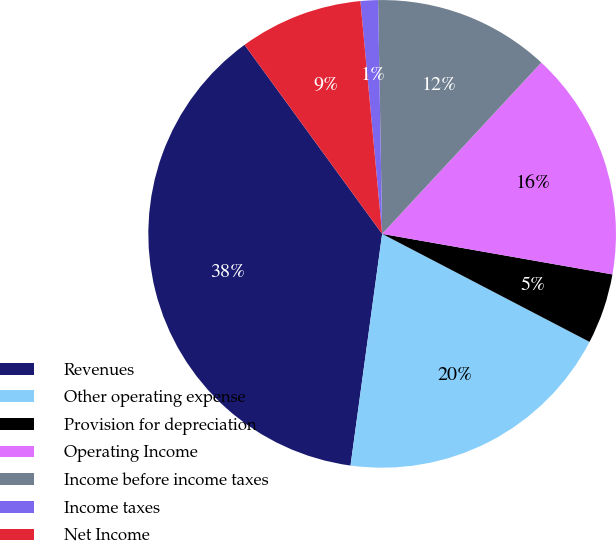Convert chart to OTSL. <chart><loc_0><loc_0><loc_500><loc_500><pie_chart><fcel>Revenues<fcel>Other operating expense<fcel>Provision for depreciation<fcel>Operating Income<fcel>Income before income taxes<fcel>Income taxes<fcel>Net Income<nl><fcel>37.83%<fcel>19.52%<fcel>4.87%<fcel>15.86%<fcel>12.19%<fcel>1.21%<fcel>8.53%<nl></chart> 